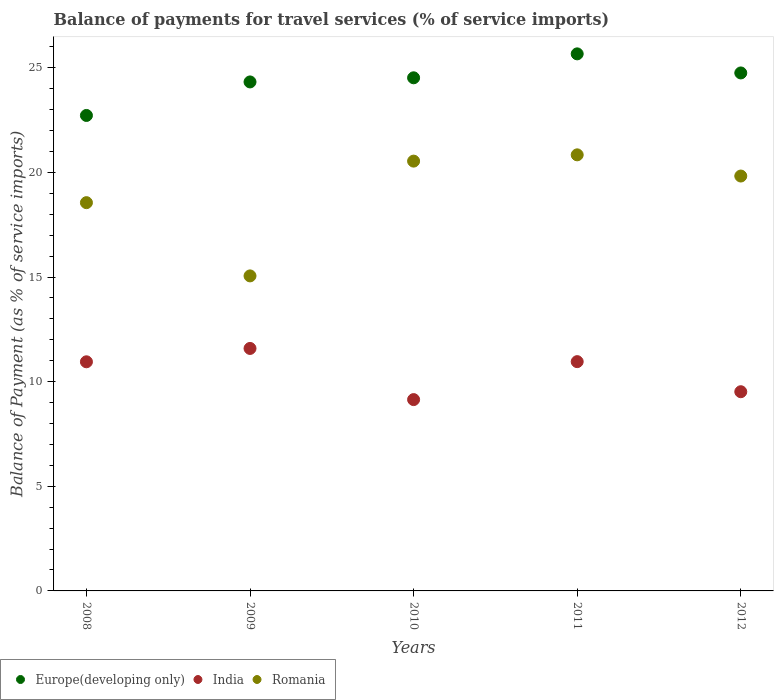How many different coloured dotlines are there?
Offer a very short reply. 3. Is the number of dotlines equal to the number of legend labels?
Ensure brevity in your answer.  Yes. What is the balance of payments for travel services in Romania in 2009?
Your response must be concise. 15.05. Across all years, what is the maximum balance of payments for travel services in India?
Your answer should be very brief. 11.59. Across all years, what is the minimum balance of payments for travel services in India?
Keep it short and to the point. 9.14. What is the total balance of payments for travel services in Romania in the graph?
Your answer should be compact. 94.8. What is the difference between the balance of payments for travel services in Romania in 2008 and that in 2010?
Offer a terse response. -1.98. What is the difference between the balance of payments for travel services in India in 2011 and the balance of payments for travel services in Romania in 2010?
Ensure brevity in your answer.  -9.58. What is the average balance of payments for travel services in Romania per year?
Your response must be concise. 18.96. In the year 2012, what is the difference between the balance of payments for travel services in Romania and balance of payments for travel services in India?
Your answer should be compact. 10.31. What is the ratio of the balance of payments for travel services in Europe(developing only) in 2009 to that in 2012?
Your answer should be very brief. 0.98. Is the difference between the balance of payments for travel services in Romania in 2008 and 2010 greater than the difference between the balance of payments for travel services in India in 2008 and 2010?
Your answer should be very brief. No. What is the difference between the highest and the second highest balance of payments for travel services in Romania?
Keep it short and to the point. 0.3. What is the difference between the highest and the lowest balance of payments for travel services in Romania?
Your answer should be compact. 5.78. Is the sum of the balance of payments for travel services in India in 2008 and 2009 greater than the maximum balance of payments for travel services in Europe(developing only) across all years?
Provide a short and direct response. No. Is the balance of payments for travel services in Europe(developing only) strictly less than the balance of payments for travel services in India over the years?
Provide a succinct answer. No. How many years are there in the graph?
Your response must be concise. 5. What is the difference between two consecutive major ticks on the Y-axis?
Ensure brevity in your answer.  5. How many legend labels are there?
Keep it short and to the point. 3. What is the title of the graph?
Ensure brevity in your answer.  Balance of payments for travel services (% of service imports). What is the label or title of the Y-axis?
Your response must be concise. Balance of Payment (as % of service imports). What is the Balance of Payment (as % of service imports) in Europe(developing only) in 2008?
Your answer should be very brief. 22.72. What is the Balance of Payment (as % of service imports) of India in 2008?
Provide a short and direct response. 10.95. What is the Balance of Payment (as % of service imports) of Romania in 2008?
Provide a short and direct response. 18.55. What is the Balance of Payment (as % of service imports) in Europe(developing only) in 2009?
Give a very brief answer. 24.32. What is the Balance of Payment (as % of service imports) in India in 2009?
Ensure brevity in your answer.  11.59. What is the Balance of Payment (as % of service imports) of Romania in 2009?
Make the answer very short. 15.05. What is the Balance of Payment (as % of service imports) of Europe(developing only) in 2010?
Offer a terse response. 24.52. What is the Balance of Payment (as % of service imports) in India in 2010?
Make the answer very short. 9.14. What is the Balance of Payment (as % of service imports) of Romania in 2010?
Your answer should be compact. 20.54. What is the Balance of Payment (as % of service imports) in Europe(developing only) in 2011?
Offer a very short reply. 25.66. What is the Balance of Payment (as % of service imports) of India in 2011?
Your answer should be compact. 10.96. What is the Balance of Payment (as % of service imports) of Romania in 2011?
Give a very brief answer. 20.84. What is the Balance of Payment (as % of service imports) in Europe(developing only) in 2012?
Offer a terse response. 24.75. What is the Balance of Payment (as % of service imports) in India in 2012?
Offer a very short reply. 9.52. What is the Balance of Payment (as % of service imports) of Romania in 2012?
Provide a short and direct response. 19.82. Across all years, what is the maximum Balance of Payment (as % of service imports) of Europe(developing only)?
Your response must be concise. 25.66. Across all years, what is the maximum Balance of Payment (as % of service imports) in India?
Your answer should be compact. 11.59. Across all years, what is the maximum Balance of Payment (as % of service imports) of Romania?
Provide a succinct answer. 20.84. Across all years, what is the minimum Balance of Payment (as % of service imports) in Europe(developing only)?
Your answer should be very brief. 22.72. Across all years, what is the minimum Balance of Payment (as % of service imports) in India?
Keep it short and to the point. 9.14. Across all years, what is the minimum Balance of Payment (as % of service imports) in Romania?
Make the answer very short. 15.05. What is the total Balance of Payment (as % of service imports) of Europe(developing only) in the graph?
Provide a short and direct response. 121.97. What is the total Balance of Payment (as % of service imports) of India in the graph?
Offer a very short reply. 52.15. What is the total Balance of Payment (as % of service imports) in Romania in the graph?
Provide a short and direct response. 94.8. What is the difference between the Balance of Payment (as % of service imports) of Europe(developing only) in 2008 and that in 2009?
Give a very brief answer. -1.6. What is the difference between the Balance of Payment (as % of service imports) of India in 2008 and that in 2009?
Offer a very short reply. -0.64. What is the difference between the Balance of Payment (as % of service imports) in Romania in 2008 and that in 2009?
Keep it short and to the point. 3.5. What is the difference between the Balance of Payment (as % of service imports) in Europe(developing only) in 2008 and that in 2010?
Give a very brief answer. -1.8. What is the difference between the Balance of Payment (as % of service imports) in India in 2008 and that in 2010?
Your answer should be compact. 1.81. What is the difference between the Balance of Payment (as % of service imports) in Romania in 2008 and that in 2010?
Your response must be concise. -1.99. What is the difference between the Balance of Payment (as % of service imports) in Europe(developing only) in 2008 and that in 2011?
Make the answer very short. -2.94. What is the difference between the Balance of Payment (as % of service imports) of India in 2008 and that in 2011?
Provide a short and direct response. -0.01. What is the difference between the Balance of Payment (as % of service imports) of Romania in 2008 and that in 2011?
Your response must be concise. -2.29. What is the difference between the Balance of Payment (as % of service imports) of Europe(developing only) in 2008 and that in 2012?
Offer a terse response. -2.03. What is the difference between the Balance of Payment (as % of service imports) of India in 2008 and that in 2012?
Offer a very short reply. 1.43. What is the difference between the Balance of Payment (as % of service imports) of Romania in 2008 and that in 2012?
Provide a succinct answer. -1.27. What is the difference between the Balance of Payment (as % of service imports) in Europe(developing only) in 2009 and that in 2010?
Your answer should be compact. -0.2. What is the difference between the Balance of Payment (as % of service imports) in India in 2009 and that in 2010?
Your answer should be compact. 2.44. What is the difference between the Balance of Payment (as % of service imports) in Romania in 2009 and that in 2010?
Ensure brevity in your answer.  -5.48. What is the difference between the Balance of Payment (as % of service imports) of Europe(developing only) in 2009 and that in 2011?
Your answer should be compact. -1.34. What is the difference between the Balance of Payment (as % of service imports) in India in 2009 and that in 2011?
Offer a terse response. 0.63. What is the difference between the Balance of Payment (as % of service imports) in Romania in 2009 and that in 2011?
Provide a succinct answer. -5.78. What is the difference between the Balance of Payment (as % of service imports) in Europe(developing only) in 2009 and that in 2012?
Offer a terse response. -0.43. What is the difference between the Balance of Payment (as % of service imports) of India in 2009 and that in 2012?
Provide a short and direct response. 2.07. What is the difference between the Balance of Payment (as % of service imports) in Romania in 2009 and that in 2012?
Keep it short and to the point. -4.77. What is the difference between the Balance of Payment (as % of service imports) of Europe(developing only) in 2010 and that in 2011?
Keep it short and to the point. -1.14. What is the difference between the Balance of Payment (as % of service imports) in India in 2010 and that in 2011?
Ensure brevity in your answer.  -1.81. What is the difference between the Balance of Payment (as % of service imports) of Romania in 2010 and that in 2011?
Provide a short and direct response. -0.3. What is the difference between the Balance of Payment (as % of service imports) in Europe(developing only) in 2010 and that in 2012?
Ensure brevity in your answer.  -0.23. What is the difference between the Balance of Payment (as % of service imports) in India in 2010 and that in 2012?
Make the answer very short. -0.38. What is the difference between the Balance of Payment (as % of service imports) in Romania in 2010 and that in 2012?
Your response must be concise. 0.71. What is the difference between the Balance of Payment (as % of service imports) of Europe(developing only) in 2011 and that in 2012?
Keep it short and to the point. 0.91. What is the difference between the Balance of Payment (as % of service imports) in India in 2011 and that in 2012?
Provide a short and direct response. 1.44. What is the difference between the Balance of Payment (as % of service imports) in Romania in 2011 and that in 2012?
Your answer should be compact. 1.01. What is the difference between the Balance of Payment (as % of service imports) of Europe(developing only) in 2008 and the Balance of Payment (as % of service imports) of India in 2009?
Give a very brief answer. 11.13. What is the difference between the Balance of Payment (as % of service imports) of Europe(developing only) in 2008 and the Balance of Payment (as % of service imports) of Romania in 2009?
Make the answer very short. 7.67. What is the difference between the Balance of Payment (as % of service imports) of India in 2008 and the Balance of Payment (as % of service imports) of Romania in 2009?
Make the answer very short. -4.1. What is the difference between the Balance of Payment (as % of service imports) in Europe(developing only) in 2008 and the Balance of Payment (as % of service imports) in India in 2010?
Provide a succinct answer. 13.58. What is the difference between the Balance of Payment (as % of service imports) in Europe(developing only) in 2008 and the Balance of Payment (as % of service imports) in Romania in 2010?
Give a very brief answer. 2.18. What is the difference between the Balance of Payment (as % of service imports) in India in 2008 and the Balance of Payment (as % of service imports) in Romania in 2010?
Your answer should be very brief. -9.59. What is the difference between the Balance of Payment (as % of service imports) in Europe(developing only) in 2008 and the Balance of Payment (as % of service imports) in India in 2011?
Offer a terse response. 11.76. What is the difference between the Balance of Payment (as % of service imports) of Europe(developing only) in 2008 and the Balance of Payment (as % of service imports) of Romania in 2011?
Provide a succinct answer. 1.88. What is the difference between the Balance of Payment (as % of service imports) of India in 2008 and the Balance of Payment (as % of service imports) of Romania in 2011?
Give a very brief answer. -9.89. What is the difference between the Balance of Payment (as % of service imports) of Europe(developing only) in 2008 and the Balance of Payment (as % of service imports) of India in 2012?
Ensure brevity in your answer.  13.2. What is the difference between the Balance of Payment (as % of service imports) in Europe(developing only) in 2008 and the Balance of Payment (as % of service imports) in Romania in 2012?
Give a very brief answer. 2.89. What is the difference between the Balance of Payment (as % of service imports) in India in 2008 and the Balance of Payment (as % of service imports) in Romania in 2012?
Offer a terse response. -8.88. What is the difference between the Balance of Payment (as % of service imports) of Europe(developing only) in 2009 and the Balance of Payment (as % of service imports) of India in 2010?
Your response must be concise. 15.18. What is the difference between the Balance of Payment (as % of service imports) of Europe(developing only) in 2009 and the Balance of Payment (as % of service imports) of Romania in 2010?
Ensure brevity in your answer.  3.78. What is the difference between the Balance of Payment (as % of service imports) of India in 2009 and the Balance of Payment (as % of service imports) of Romania in 2010?
Provide a short and direct response. -8.95. What is the difference between the Balance of Payment (as % of service imports) in Europe(developing only) in 2009 and the Balance of Payment (as % of service imports) in India in 2011?
Your answer should be compact. 13.37. What is the difference between the Balance of Payment (as % of service imports) in Europe(developing only) in 2009 and the Balance of Payment (as % of service imports) in Romania in 2011?
Your answer should be compact. 3.48. What is the difference between the Balance of Payment (as % of service imports) of India in 2009 and the Balance of Payment (as % of service imports) of Romania in 2011?
Your answer should be very brief. -9.25. What is the difference between the Balance of Payment (as % of service imports) of Europe(developing only) in 2009 and the Balance of Payment (as % of service imports) of India in 2012?
Offer a very short reply. 14.8. What is the difference between the Balance of Payment (as % of service imports) of Europe(developing only) in 2009 and the Balance of Payment (as % of service imports) of Romania in 2012?
Make the answer very short. 4.5. What is the difference between the Balance of Payment (as % of service imports) of India in 2009 and the Balance of Payment (as % of service imports) of Romania in 2012?
Your answer should be very brief. -8.24. What is the difference between the Balance of Payment (as % of service imports) in Europe(developing only) in 2010 and the Balance of Payment (as % of service imports) in India in 2011?
Give a very brief answer. 13.56. What is the difference between the Balance of Payment (as % of service imports) of Europe(developing only) in 2010 and the Balance of Payment (as % of service imports) of Romania in 2011?
Provide a succinct answer. 3.68. What is the difference between the Balance of Payment (as % of service imports) in India in 2010 and the Balance of Payment (as % of service imports) in Romania in 2011?
Your answer should be very brief. -11.7. What is the difference between the Balance of Payment (as % of service imports) of Europe(developing only) in 2010 and the Balance of Payment (as % of service imports) of India in 2012?
Your answer should be very brief. 15. What is the difference between the Balance of Payment (as % of service imports) in Europe(developing only) in 2010 and the Balance of Payment (as % of service imports) in Romania in 2012?
Your response must be concise. 4.69. What is the difference between the Balance of Payment (as % of service imports) of India in 2010 and the Balance of Payment (as % of service imports) of Romania in 2012?
Offer a terse response. -10.68. What is the difference between the Balance of Payment (as % of service imports) of Europe(developing only) in 2011 and the Balance of Payment (as % of service imports) of India in 2012?
Your answer should be compact. 16.14. What is the difference between the Balance of Payment (as % of service imports) in Europe(developing only) in 2011 and the Balance of Payment (as % of service imports) in Romania in 2012?
Keep it short and to the point. 5.84. What is the difference between the Balance of Payment (as % of service imports) in India in 2011 and the Balance of Payment (as % of service imports) in Romania in 2012?
Keep it short and to the point. -8.87. What is the average Balance of Payment (as % of service imports) in Europe(developing only) per year?
Keep it short and to the point. 24.39. What is the average Balance of Payment (as % of service imports) in India per year?
Make the answer very short. 10.43. What is the average Balance of Payment (as % of service imports) in Romania per year?
Your response must be concise. 18.96. In the year 2008, what is the difference between the Balance of Payment (as % of service imports) of Europe(developing only) and Balance of Payment (as % of service imports) of India?
Provide a short and direct response. 11.77. In the year 2008, what is the difference between the Balance of Payment (as % of service imports) in Europe(developing only) and Balance of Payment (as % of service imports) in Romania?
Ensure brevity in your answer.  4.17. In the year 2008, what is the difference between the Balance of Payment (as % of service imports) in India and Balance of Payment (as % of service imports) in Romania?
Your answer should be compact. -7.6. In the year 2009, what is the difference between the Balance of Payment (as % of service imports) of Europe(developing only) and Balance of Payment (as % of service imports) of India?
Ensure brevity in your answer.  12.73. In the year 2009, what is the difference between the Balance of Payment (as % of service imports) in Europe(developing only) and Balance of Payment (as % of service imports) in Romania?
Your answer should be very brief. 9.27. In the year 2009, what is the difference between the Balance of Payment (as % of service imports) of India and Balance of Payment (as % of service imports) of Romania?
Provide a succinct answer. -3.47. In the year 2010, what is the difference between the Balance of Payment (as % of service imports) of Europe(developing only) and Balance of Payment (as % of service imports) of India?
Your answer should be very brief. 15.38. In the year 2010, what is the difference between the Balance of Payment (as % of service imports) in Europe(developing only) and Balance of Payment (as % of service imports) in Romania?
Offer a very short reply. 3.98. In the year 2010, what is the difference between the Balance of Payment (as % of service imports) of India and Balance of Payment (as % of service imports) of Romania?
Your answer should be very brief. -11.4. In the year 2011, what is the difference between the Balance of Payment (as % of service imports) of Europe(developing only) and Balance of Payment (as % of service imports) of India?
Make the answer very short. 14.71. In the year 2011, what is the difference between the Balance of Payment (as % of service imports) of Europe(developing only) and Balance of Payment (as % of service imports) of Romania?
Provide a succinct answer. 4.83. In the year 2011, what is the difference between the Balance of Payment (as % of service imports) of India and Balance of Payment (as % of service imports) of Romania?
Your answer should be compact. -9.88. In the year 2012, what is the difference between the Balance of Payment (as % of service imports) in Europe(developing only) and Balance of Payment (as % of service imports) in India?
Offer a terse response. 15.23. In the year 2012, what is the difference between the Balance of Payment (as % of service imports) in Europe(developing only) and Balance of Payment (as % of service imports) in Romania?
Make the answer very short. 4.93. In the year 2012, what is the difference between the Balance of Payment (as % of service imports) in India and Balance of Payment (as % of service imports) in Romania?
Give a very brief answer. -10.31. What is the ratio of the Balance of Payment (as % of service imports) in Europe(developing only) in 2008 to that in 2009?
Provide a succinct answer. 0.93. What is the ratio of the Balance of Payment (as % of service imports) in India in 2008 to that in 2009?
Offer a very short reply. 0.94. What is the ratio of the Balance of Payment (as % of service imports) of Romania in 2008 to that in 2009?
Keep it short and to the point. 1.23. What is the ratio of the Balance of Payment (as % of service imports) in Europe(developing only) in 2008 to that in 2010?
Your answer should be very brief. 0.93. What is the ratio of the Balance of Payment (as % of service imports) of India in 2008 to that in 2010?
Make the answer very short. 1.2. What is the ratio of the Balance of Payment (as % of service imports) in Romania in 2008 to that in 2010?
Keep it short and to the point. 0.9. What is the ratio of the Balance of Payment (as % of service imports) in Europe(developing only) in 2008 to that in 2011?
Your response must be concise. 0.89. What is the ratio of the Balance of Payment (as % of service imports) in India in 2008 to that in 2011?
Provide a short and direct response. 1. What is the ratio of the Balance of Payment (as % of service imports) of Romania in 2008 to that in 2011?
Offer a very short reply. 0.89. What is the ratio of the Balance of Payment (as % of service imports) in Europe(developing only) in 2008 to that in 2012?
Offer a very short reply. 0.92. What is the ratio of the Balance of Payment (as % of service imports) of India in 2008 to that in 2012?
Offer a terse response. 1.15. What is the ratio of the Balance of Payment (as % of service imports) of Romania in 2008 to that in 2012?
Your answer should be very brief. 0.94. What is the ratio of the Balance of Payment (as % of service imports) in India in 2009 to that in 2010?
Ensure brevity in your answer.  1.27. What is the ratio of the Balance of Payment (as % of service imports) in Romania in 2009 to that in 2010?
Offer a terse response. 0.73. What is the ratio of the Balance of Payment (as % of service imports) in Europe(developing only) in 2009 to that in 2011?
Your answer should be compact. 0.95. What is the ratio of the Balance of Payment (as % of service imports) of India in 2009 to that in 2011?
Your answer should be compact. 1.06. What is the ratio of the Balance of Payment (as % of service imports) in Romania in 2009 to that in 2011?
Offer a terse response. 0.72. What is the ratio of the Balance of Payment (as % of service imports) in Europe(developing only) in 2009 to that in 2012?
Offer a very short reply. 0.98. What is the ratio of the Balance of Payment (as % of service imports) of India in 2009 to that in 2012?
Make the answer very short. 1.22. What is the ratio of the Balance of Payment (as % of service imports) in Romania in 2009 to that in 2012?
Your answer should be compact. 0.76. What is the ratio of the Balance of Payment (as % of service imports) of Europe(developing only) in 2010 to that in 2011?
Your answer should be very brief. 0.96. What is the ratio of the Balance of Payment (as % of service imports) of India in 2010 to that in 2011?
Your answer should be very brief. 0.83. What is the ratio of the Balance of Payment (as % of service imports) in Romania in 2010 to that in 2011?
Make the answer very short. 0.99. What is the ratio of the Balance of Payment (as % of service imports) in Europe(developing only) in 2010 to that in 2012?
Give a very brief answer. 0.99. What is the ratio of the Balance of Payment (as % of service imports) of India in 2010 to that in 2012?
Your answer should be very brief. 0.96. What is the ratio of the Balance of Payment (as % of service imports) of Romania in 2010 to that in 2012?
Provide a succinct answer. 1.04. What is the ratio of the Balance of Payment (as % of service imports) in Europe(developing only) in 2011 to that in 2012?
Your response must be concise. 1.04. What is the ratio of the Balance of Payment (as % of service imports) in India in 2011 to that in 2012?
Your answer should be compact. 1.15. What is the ratio of the Balance of Payment (as % of service imports) in Romania in 2011 to that in 2012?
Ensure brevity in your answer.  1.05. What is the difference between the highest and the second highest Balance of Payment (as % of service imports) of Europe(developing only)?
Your response must be concise. 0.91. What is the difference between the highest and the second highest Balance of Payment (as % of service imports) of India?
Keep it short and to the point. 0.63. What is the difference between the highest and the second highest Balance of Payment (as % of service imports) in Romania?
Your response must be concise. 0.3. What is the difference between the highest and the lowest Balance of Payment (as % of service imports) of Europe(developing only)?
Keep it short and to the point. 2.94. What is the difference between the highest and the lowest Balance of Payment (as % of service imports) in India?
Your answer should be compact. 2.44. What is the difference between the highest and the lowest Balance of Payment (as % of service imports) of Romania?
Give a very brief answer. 5.78. 